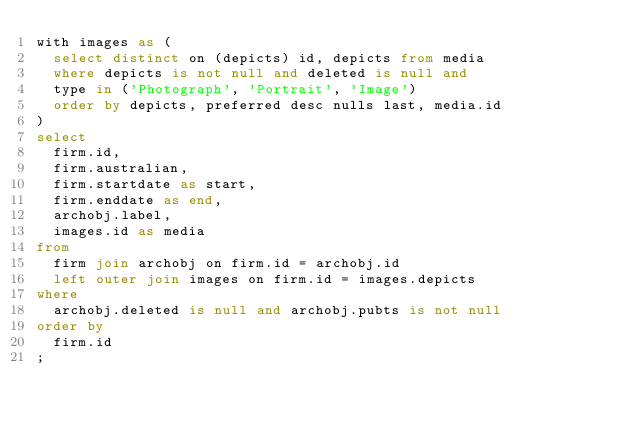Convert code to text. <code><loc_0><loc_0><loc_500><loc_500><_SQL_>with images as (
  select distinct on (depicts) id, depicts from media
  where depicts is not null and deleted is null and
  type in ('Photograph', 'Portrait', 'Image')
  order by depicts, preferred desc nulls last, media.id
)
select
  firm.id,
  firm.australian,
  firm.startdate as start,
  firm.enddate as end,
  archobj.label,
  images.id as media
from
  firm join archobj on firm.id = archobj.id
  left outer join images on firm.id = images.depicts
where
  archobj.deleted is null and archobj.pubts is not null
order by
  firm.id
;</code> 